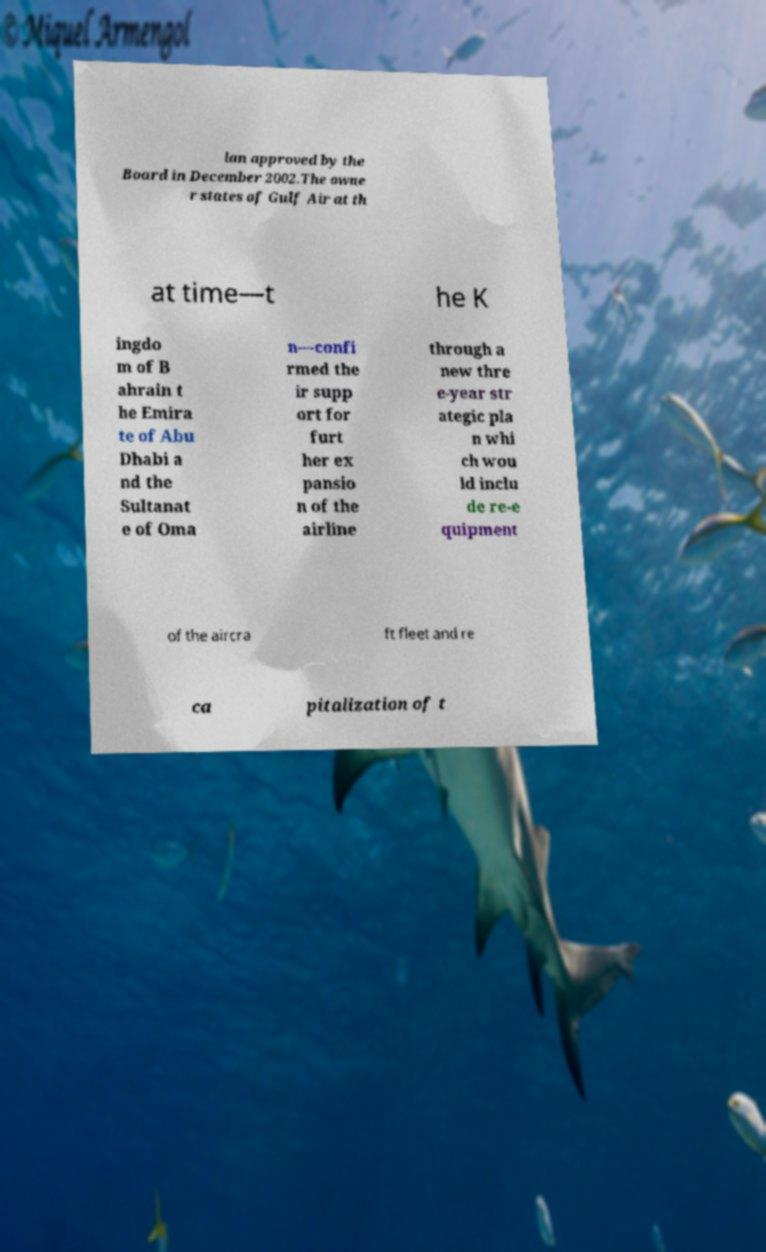There's text embedded in this image that I need extracted. Can you transcribe it verbatim? lan approved by the Board in December 2002.The owne r states of Gulf Air at th at time—t he K ingdo m of B ahrain t he Emira te of Abu Dhabi a nd the Sultanat e of Oma n—confi rmed the ir supp ort for furt her ex pansio n of the airline through a new thre e-year str ategic pla n whi ch wou ld inclu de re-e quipment of the aircra ft fleet and re ca pitalization of t 